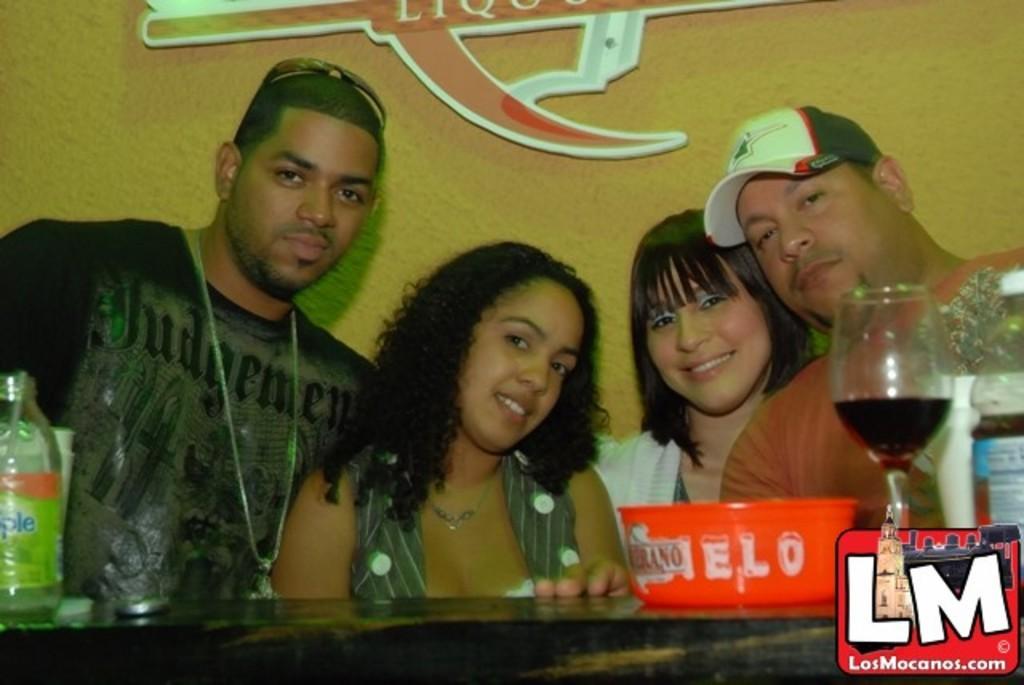Could you give a brief overview of what you see in this image? In this picture there are people and we can see bottles, glass with drink, bowl and objects on the platform. In the background of the image we can see a board on the wall. In the bottom right side of the image we can see a logo. 